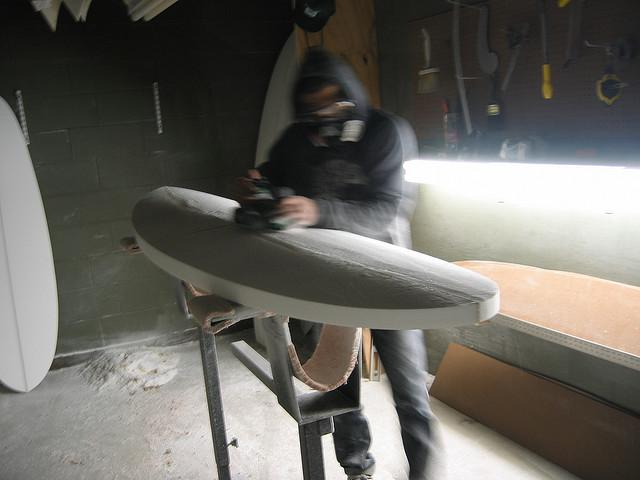What is the man wearing on his head? Please explain your reasoning. hood. This is worn to prevent inhalation of small particles that are present during sanding and object. 